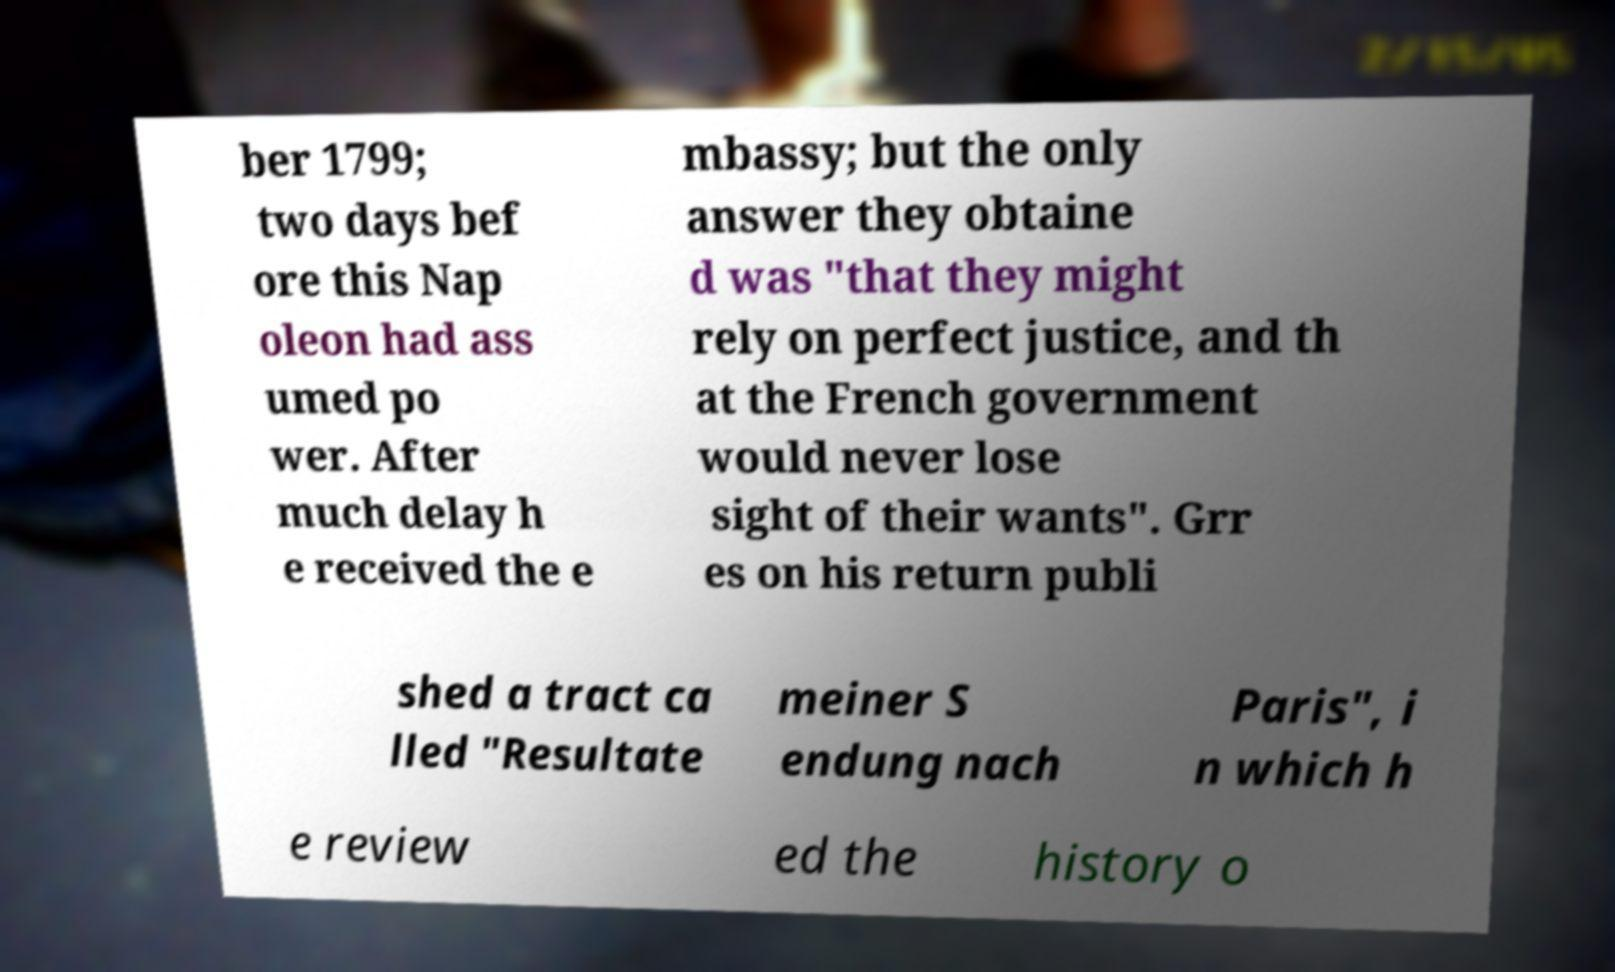Could you extract and type out the text from this image? ber 1799; two days bef ore this Nap oleon had ass umed po wer. After much delay h e received the e mbassy; but the only answer they obtaine d was "that they might rely on perfect justice, and th at the French government would never lose sight of their wants". Grr es on his return publi shed a tract ca lled "Resultate meiner S endung nach Paris", i n which h e review ed the history o 